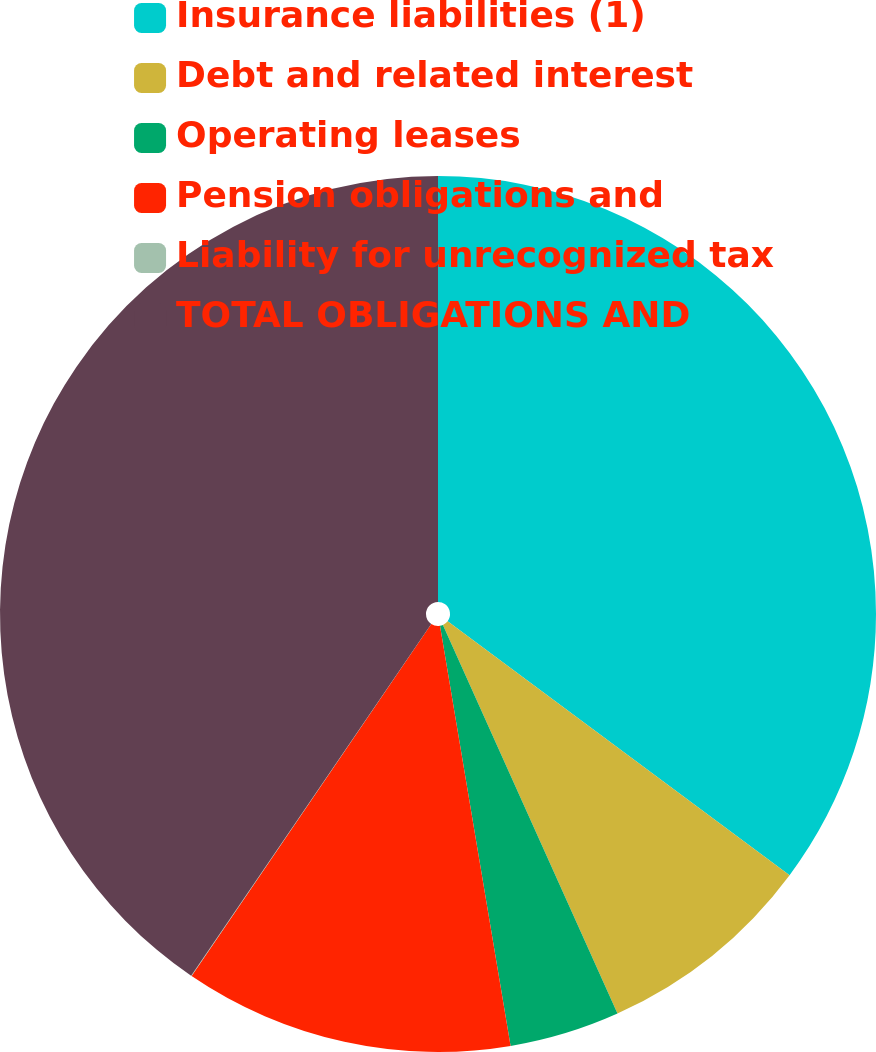Convert chart. <chart><loc_0><loc_0><loc_500><loc_500><pie_chart><fcel>Insurance liabilities (1)<fcel>Debt and related interest<fcel>Operating leases<fcel>Pension obligations and<fcel>Liability for unrecognized tax<fcel>TOTAL OBLIGATIONS AND<nl><fcel>35.17%<fcel>8.11%<fcel>4.07%<fcel>12.16%<fcel>0.02%<fcel>40.47%<nl></chart> 